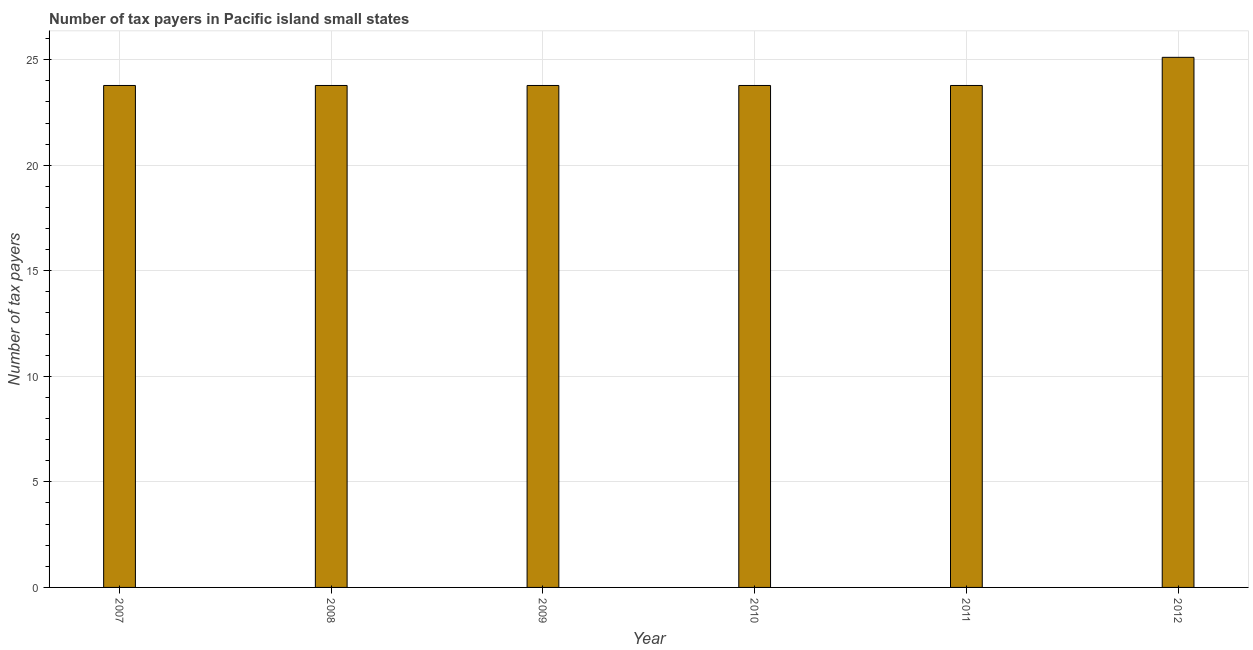What is the title of the graph?
Offer a terse response. Number of tax payers in Pacific island small states. What is the label or title of the X-axis?
Offer a very short reply. Year. What is the label or title of the Y-axis?
Give a very brief answer. Number of tax payers. What is the number of tax payers in 2012?
Make the answer very short. 25.11. Across all years, what is the maximum number of tax payers?
Your answer should be very brief. 25.11. Across all years, what is the minimum number of tax payers?
Provide a succinct answer. 23.78. What is the sum of the number of tax payers?
Provide a succinct answer. 144. What is the median number of tax payers?
Keep it short and to the point. 23.78. Do a majority of the years between 2008 and 2010 (inclusive) have number of tax payers greater than 1 ?
Your answer should be compact. Yes. What is the ratio of the number of tax payers in 2011 to that in 2012?
Your response must be concise. 0.95. Is the difference between the number of tax payers in 2008 and 2010 greater than the difference between any two years?
Your answer should be very brief. No. What is the difference between the highest and the second highest number of tax payers?
Your answer should be very brief. 1.33. What is the difference between the highest and the lowest number of tax payers?
Make the answer very short. 1.33. In how many years, is the number of tax payers greater than the average number of tax payers taken over all years?
Provide a short and direct response. 1. How many bars are there?
Your answer should be very brief. 6. Are the values on the major ticks of Y-axis written in scientific E-notation?
Provide a short and direct response. No. What is the Number of tax payers of 2007?
Make the answer very short. 23.78. What is the Number of tax payers of 2008?
Give a very brief answer. 23.78. What is the Number of tax payers of 2009?
Ensure brevity in your answer.  23.78. What is the Number of tax payers in 2010?
Offer a very short reply. 23.78. What is the Number of tax payers in 2011?
Your answer should be very brief. 23.78. What is the Number of tax payers in 2012?
Offer a terse response. 25.11. What is the difference between the Number of tax payers in 2007 and 2008?
Your answer should be compact. 0. What is the difference between the Number of tax payers in 2007 and 2012?
Make the answer very short. -1.33. What is the difference between the Number of tax payers in 2008 and 2012?
Give a very brief answer. -1.33. What is the difference between the Number of tax payers in 2009 and 2011?
Your answer should be compact. 0. What is the difference between the Number of tax payers in 2009 and 2012?
Give a very brief answer. -1.33. What is the difference between the Number of tax payers in 2010 and 2011?
Keep it short and to the point. 0. What is the difference between the Number of tax payers in 2010 and 2012?
Ensure brevity in your answer.  -1.33. What is the difference between the Number of tax payers in 2011 and 2012?
Your response must be concise. -1.33. What is the ratio of the Number of tax payers in 2007 to that in 2009?
Keep it short and to the point. 1. What is the ratio of the Number of tax payers in 2007 to that in 2010?
Provide a succinct answer. 1. What is the ratio of the Number of tax payers in 2007 to that in 2012?
Make the answer very short. 0.95. What is the ratio of the Number of tax payers in 2008 to that in 2009?
Give a very brief answer. 1. What is the ratio of the Number of tax payers in 2008 to that in 2010?
Your answer should be compact. 1. What is the ratio of the Number of tax payers in 2008 to that in 2012?
Offer a very short reply. 0.95. What is the ratio of the Number of tax payers in 2009 to that in 2010?
Keep it short and to the point. 1. What is the ratio of the Number of tax payers in 2009 to that in 2012?
Make the answer very short. 0.95. What is the ratio of the Number of tax payers in 2010 to that in 2012?
Provide a succinct answer. 0.95. What is the ratio of the Number of tax payers in 2011 to that in 2012?
Keep it short and to the point. 0.95. 